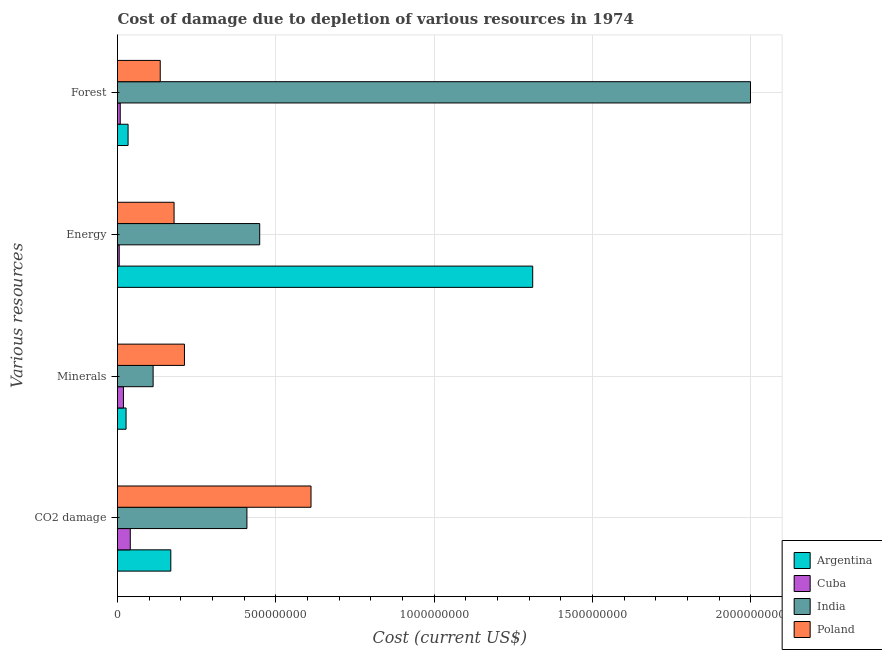How many different coloured bars are there?
Offer a very short reply. 4. How many groups of bars are there?
Offer a terse response. 4. Are the number of bars per tick equal to the number of legend labels?
Keep it short and to the point. Yes. What is the label of the 4th group of bars from the top?
Provide a succinct answer. CO2 damage. What is the cost of damage due to depletion of minerals in Argentina?
Provide a short and direct response. 2.70e+07. Across all countries, what is the maximum cost of damage due to depletion of coal?
Make the answer very short. 6.11e+08. Across all countries, what is the minimum cost of damage due to depletion of energy?
Your answer should be compact. 5.37e+06. In which country was the cost of damage due to depletion of minerals maximum?
Make the answer very short. Poland. In which country was the cost of damage due to depletion of minerals minimum?
Make the answer very short. Cuba. What is the total cost of damage due to depletion of energy in the graph?
Provide a short and direct response. 1.94e+09. What is the difference between the cost of damage due to depletion of energy in India and that in Poland?
Keep it short and to the point. 2.70e+08. What is the difference between the cost of damage due to depletion of coal in Poland and the cost of damage due to depletion of minerals in Argentina?
Offer a very short reply. 5.84e+08. What is the average cost of damage due to depletion of coal per country?
Keep it short and to the point. 3.07e+08. What is the difference between the cost of damage due to depletion of coal and cost of damage due to depletion of forests in Poland?
Give a very brief answer. 4.76e+08. What is the ratio of the cost of damage due to depletion of coal in Cuba to that in India?
Offer a terse response. 0.1. Is the difference between the cost of damage due to depletion of forests in Poland and Argentina greater than the difference between the cost of damage due to depletion of minerals in Poland and Argentina?
Provide a succinct answer. No. What is the difference between the highest and the second highest cost of damage due to depletion of minerals?
Make the answer very short. 9.90e+07. What is the difference between the highest and the lowest cost of damage due to depletion of energy?
Your answer should be very brief. 1.31e+09. Is the sum of the cost of damage due to depletion of forests in India and Argentina greater than the maximum cost of damage due to depletion of energy across all countries?
Your response must be concise. Yes. Is it the case that in every country, the sum of the cost of damage due to depletion of forests and cost of damage due to depletion of coal is greater than the sum of cost of damage due to depletion of energy and cost of damage due to depletion of minerals?
Ensure brevity in your answer.  No. What does the 3rd bar from the bottom in Forest represents?
Provide a short and direct response. India. How many bars are there?
Provide a short and direct response. 16. How many countries are there in the graph?
Provide a succinct answer. 4. What is the difference between two consecutive major ticks on the X-axis?
Your answer should be compact. 5.00e+08. Are the values on the major ticks of X-axis written in scientific E-notation?
Ensure brevity in your answer.  No. Does the graph contain any zero values?
Offer a very short reply. No. How are the legend labels stacked?
Your response must be concise. Vertical. What is the title of the graph?
Give a very brief answer. Cost of damage due to depletion of various resources in 1974 . Does "Seychelles" appear as one of the legend labels in the graph?
Offer a terse response. No. What is the label or title of the X-axis?
Your answer should be very brief. Cost (current US$). What is the label or title of the Y-axis?
Your answer should be compact. Various resources. What is the Cost (current US$) of Argentina in CO2 damage?
Provide a short and direct response. 1.68e+08. What is the Cost (current US$) in Cuba in CO2 damage?
Keep it short and to the point. 4.04e+07. What is the Cost (current US$) in India in CO2 damage?
Your response must be concise. 4.09e+08. What is the Cost (current US$) in Poland in CO2 damage?
Ensure brevity in your answer.  6.11e+08. What is the Cost (current US$) of Argentina in Minerals?
Provide a succinct answer. 2.70e+07. What is the Cost (current US$) of Cuba in Minerals?
Offer a very short reply. 1.88e+07. What is the Cost (current US$) of India in Minerals?
Ensure brevity in your answer.  1.12e+08. What is the Cost (current US$) of Poland in Minerals?
Offer a very short reply. 2.11e+08. What is the Cost (current US$) in Argentina in Energy?
Your response must be concise. 1.31e+09. What is the Cost (current US$) in Cuba in Energy?
Your answer should be compact. 5.37e+06. What is the Cost (current US$) of India in Energy?
Keep it short and to the point. 4.49e+08. What is the Cost (current US$) of Poland in Energy?
Make the answer very short. 1.79e+08. What is the Cost (current US$) in Argentina in Forest?
Provide a short and direct response. 3.34e+07. What is the Cost (current US$) of Cuba in Forest?
Provide a short and direct response. 8.61e+06. What is the Cost (current US$) of India in Forest?
Your response must be concise. 2.00e+09. What is the Cost (current US$) of Poland in Forest?
Provide a succinct answer. 1.35e+08. Across all Various resources, what is the maximum Cost (current US$) in Argentina?
Provide a short and direct response. 1.31e+09. Across all Various resources, what is the maximum Cost (current US$) of Cuba?
Provide a succinct answer. 4.04e+07. Across all Various resources, what is the maximum Cost (current US$) in India?
Give a very brief answer. 2.00e+09. Across all Various resources, what is the maximum Cost (current US$) in Poland?
Your answer should be very brief. 6.11e+08. Across all Various resources, what is the minimum Cost (current US$) of Argentina?
Provide a succinct answer. 2.70e+07. Across all Various resources, what is the minimum Cost (current US$) in Cuba?
Provide a short and direct response. 5.37e+06. Across all Various resources, what is the minimum Cost (current US$) of India?
Offer a terse response. 1.12e+08. Across all Various resources, what is the minimum Cost (current US$) in Poland?
Your answer should be compact. 1.35e+08. What is the total Cost (current US$) of Argentina in the graph?
Ensure brevity in your answer.  1.54e+09. What is the total Cost (current US$) of Cuba in the graph?
Make the answer very short. 7.31e+07. What is the total Cost (current US$) in India in the graph?
Make the answer very short. 2.97e+09. What is the total Cost (current US$) in Poland in the graph?
Offer a terse response. 1.14e+09. What is the difference between the Cost (current US$) of Argentina in CO2 damage and that in Minerals?
Keep it short and to the point. 1.41e+08. What is the difference between the Cost (current US$) of Cuba in CO2 damage and that in Minerals?
Your answer should be very brief. 2.16e+07. What is the difference between the Cost (current US$) of India in CO2 damage and that in Minerals?
Give a very brief answer. 2.96e+08. What is the difference between the Cost (current US$) in Poland in CO2 damage and that in Minerals?
Provide a short and direct response. 4.00e+08. What is the difference between the Cost (current US$) of Argentina in CO2 damage and that in Energy?
Keep it short and to the point. -1.14e+09. What is the difference between the Cost (current US$) of Cuba in CO2 damage and that in Energy?
Your answer should be compact. 3.50e+07. What is the difference between the Cost (current US$) of India in CO2 damage and that in Energy?
Give a very brief answer. -4.04e+07. What is the difference between the Cost (current US$) of Poland in CO2 damage and that in Energy?
Offer a terse response. 4.33e+08. What is the difference between the Cost (current US$) in Argentina in CO2 damage and that in Forest?
Ensure brevity in your answer.  1.35e+08. What is the difference between the Cost (current US$) in Cuba in CO2 damage and that in Forest?
Provide a short and direct response. 3.18e+07. What is the difference between the Cost (current US$) of India in CO2 damage and that in Forest?
Make the answer very short. -1.59e+09. What is the difference between the Cost (current US$) in Poland in CO2 damage and that in Forest?
Your answer should be very brief. 4.76e+08. What is the difference between the Cost (current US$) of Argentina in Minerals and that in Energy?
Give a very brief answer. -1.28e+09. What is the difference between the Cost (current US$) of Cuba in Minerals and that in Energy?
Offer a terse response. 1.34e+07. What is the difference between the Cost (current US$) in India in Minerals and that in Energy?
Make the answer very short. -3.37e+08. What is the difference between the Cost (current US$) of Poland in Minerals and that in Energy?
Your answer should be compact. 3.28e+07. What is the difference between the Cost (current US$) in Argentina in Minerals and that in Forest?
Ensure brevity in your answer.  -6.35e+06. What is the difference between the Cost (current US$) of Cuba in Minerals and that in Forest?
Keep it short and to the point. 1.01e+07. What is the difference between the Cost (current US$) of India in Minerals and that in Forest?
Give a very brief answer. -1.89e+09. What is the difference between the Cost (current US$) of Poland in Minerals and that in Forest?
Offer a very short reply. 7.65e+07. What is the difference between the Cost (current US$) in Argentina in Energy and that in Forest?
Offer a terse response. 1.28e+09. What is the difference between the Cost (current US$) of Cuba in Energy and that in Forest?
Offer a terse response. -3.24e+06. What is the difference between the Cost (current US$) of India in Energy and that in Forest?
Offer a terse response. -1.55e+09. What is the difference between the Cost (current US$) in Poland in Energy and that in Forest?
Provide a short and direct response. 4.37e+07. What is the difference between the Cost (current US$) of Argentina in CO2 damage and the Cost (current US$) of Cuba in Minerals?
Your answer should be compact. 1.50e+08. What is the difference between the Cost (current US$) of Argentina in CO2 damage and the Cost (current US$) of India in Minerals?
Make the answer very short. 5.59e+07. What is the difference between the Cost (current US$) of Argentina in CO2 damage and the Cost (current US$) of Poland in Minerals?
Provide a succinct answer. -4.31e+07. What is the difference between the Cost (current US$) of Cuba in CO2 damage and the Cost (current US$) of India in Minerals?
Your answer should be compact. -7.21e+07. What is the difference between the Cost (current US$) of Cuba in CO2 damage and the Cost (current US$) of Poland in Minerals?
Keep it short and to the point. -1.71e+08. What is the difference between the Cost (current US$) in India in CO2 damage and the Cost (current US$) in Poland in Minerals?
Your response must be concise. 1.97e+08. What is the difference between the Cost (current US$) in Argentina in CO2 damage and the Cost (current US$) in Cuba in Energy?
Your answer should be compact. 1.63e+08. What is the difference between the Cost (current US$) of Argentina in CO2 damage and the Cost (current US$) of India in Energy?
Keep it short and to the point. -2.81e+08. What is the difference between the Cost (current US$) of Argentina in CO2 damage and the Cost (current US$) of Poland in Energy?
Offer a terse response. -1.03e+07. What is the difference between the Cost (current US$) of Cuba in CO2 damage and the Cost (current US$) of India in Energy?
Provide a short and direct response. -4.09e+08. What is the difference between the Cost (current US$) of Cuba in CO2 damage and the Cost (current US$) of Poland in Energy?
Give a very brief answer. -1.38e+08. What is the difference between the Cost (current US$) in India in CO2 damage and the Cost (current US$) in Poland in Energy?
Keep it short and to the point. 2.30e+08. What is the difference between the Cost (current US$) in Argentina in CO2 damage and the Cost (current US$) in Cuba in Forest?
Ensure brevity in your answer.  1.60e+08. What is the difference between the Cost (current US$) in Argentina in CO2 damage and the Cost (current US$) in India in Forest?
Provide a short and direct response. -1.83e+09. What is the difference between the Cost (current US$) in Argentina in CO2 damage and the Cost (current US$) in Poland in Forest?
Make the answer very short. 3.34e+07. What is the difference between the Cost (current US$) in Cuba in CO2 damage and the Cost (current US$) in India in Forest?
Offer a very short reply. -1.96e+09. What is the difference between the Cost (current US$) in Cuba in CO2 damage and the Cost (current US$) in Poland in Forest?
Your answer should be compact. -9.46e+07. What is the difference between the Cost (current US$) of India in CO2 damage and the Cost (current US$) of Poland in Forest?
Provide a short and direct response. 2.74e+08. What is the difference between the Cost (current US$) of Argentina in Minerals and the Cost (current US$) of Cuba in Energy?
Keep it short and to the point. 2.17e+07. What is the difference between the Cost (current US$) of Argentina in Minerals and the Cost (current US$) of India in Energy?
Offer a very short reply. -4.22e+08. What is the difference between the Cost (current US$) in Argentina in Minerals and the Cost (current US$) in Poland in Energy?
Your answer should be very brief. -1.52e+08. What is the difference between the Cost (current US$) in Cuba in Minerals and the Cost (current US$) in India in Energy?
Your answer should be compact. -4.30e+08. What is the difference between the Cost (current US$) in Cuba in Minerals and the Cost (current US$) in Poland in Energy?
Provide a succinct answer. -1.60e+08. What is the difference between the Cost (current US$) of India in Minerals and the Cost (current US$) of Poland in Energy?
Offer a terse response. -6.62e+07. What is the difference between the Cost (current US$) in Argentina in Minerals and the Cost (current US$) in Cuba in Forest?
Your answer should be very brief. 1.84e+07. What is the difference between the Cost (current US$) of Argentina in Minerals and the Cost (current US$) of India in Forest?
Ensure brevity in your answer.  -1.97e+09. What is the difference between the Cost (current US$) in Argentina in Minerals and the Cost (current US$) in Poland in Forest?
Your response must be concise. -1.08e+08. What is the difference between the Cost (current US$) of Cuba in Minerals and the Cost (current US$) of India in Forest?
Give a very brief answer. -1.98e+09. What is the difference between the Cost (current US$) of Cuba in Minerals and the Cost (current US$) of Poland in Forest?
Offer a very short reply. -1.16e+08. What is the difference between the Cost (current US$) in India in Minerals and the Cost (current US$) in Poland in Forest?
Make the answer very short. -2.25e+07. What is the difference between the Cost (current US$) in Argentina in Energy and the Cost (current US$) in Cuba in Forest?
Your response must be concise. 1.30e+09. What is the difference between the Cost (current US$) in Argentina in Energy and the Cost (current US$) in India in Forest?
Offer a terse response. -6.88e+08. What is the difference between the Cost (current US$) in Argentina in Energy and the Cost (current US$) in Poland in Forest?
Make the answer very short. 1.18e+09. What is the difference between the Cost (current US$) of Cuba in Energy and the Cost (current US$) of India in Forest?
Your response must be concise. -1.99e+09. What is the difference between the Cost (current US$) in Cuba in Energy and the Cost (current US$) in Poland in Forest?
Your answer should be very brief. -1.30e+08. What is the difference between the Cost (current US$) in India in Energy and the Cost (current US$) in Poland in Forest?
Give a very brief answer. 3.14e+08. What is the average Cost (current US$) of Argentina per Various resources?
Offer a terse response. 3.85e+08. What is the average Cost (current US$) in Cuba per Various resources?
Your answer should be very brief. 1.83e+07. What is the average Cost (current US$) in India per Various resources?
Keep it short and to the point. 7.42e+08. What is the average Cost (current US$) of Poland per Various resources?
Offer a terse response. 2.84e+08. What is the difference between the Cost (current US$) of Argentina and Cost (current US$) of Cuba in CO2 damage?
Offer a very short reply. 1.28e+08. What is the difference between the Cost (current US$) in Argentina and Cost (current US$) in India in CO2 damage?
Your answer should be very brief. -2.40e+08. What is the difference between the Cost (current US$) of Argentina and Cost (current US$) of Poland in CO2 damage?
Make the answer very short. -4.43e+08. What is the difference between the Cost (current US$) in Cuba and Cost (current US$) in India in CO2 damage?
Ensure brevity in your answer.  -3.68e+08. What is the difference between the Cost (current US$) in Cuba and Cost (current US$) in Poland in CO2 damage?
Your answer should be very brief. -5.71e+08. What is the difference between the Cost (current US$) in India and Cost (current US$) in Poland in CO2 damage?
Your response must be concise. -2.02e+08. What is the difference between the Cost (current US$) in Argentina and Cost (current US$) in Cuba in Minerals?
Provide a short and direct response. 8.27e+06. What is the difference between the Cost (current US$) in Argentina and Cost (current US$) in India in Minerals?
Keep it short and to the point. -8.55e+07. What is the difference between the Cost (current US$) in Argentina and Cost (current US$) in Poland in Minerals?
Offer a very short reply. -1.84e+08. What is the difference between the Cost (current US$) in Cuba and Cost (current US$) in India in Minerals?
Provide a short and direct response. -9.37e+07. What is the difference between the Cost (current US$) of Cuba and Cost (current US$) of Poland in Minerals?
Give a very brief answer. -1.93e+08. What is the difference between the Cost (current US$) in India and Cost (current US$) in Poland in Minerals?
Ensure brevity in your answer.  -9.90e+07. What is the difference between the Cost (current US$) of Argentina and Cost (current US$) of Cuba in Energy?
Provide a succinct answer. 1.31e+09. What is the difference between the Cost (current US$) in Argentina and Cost (current US$) in India in Energy?
Make the answer very short. 8.62e+08. What is the difference between the Cost (current US$) of Argentina and Cost (current US$) of Poland in Energy?
Give a very brief answer. 1.13e+09. What is the difference between the Cost (current US$) in Cuba and Cost (current US$) in India in Energy?
Provide a succinct answer. -4.44e+08. What is the difference between the Cost (current US$) in Cuba and Cost (current US$) in Poland in Energy?
Ensure brevity in your answer.  -1.73e+08. What is the difference between the Cost (current US$) of India and Cost (current US$) of Poland in Energy?
Give a very brief answer. 2.70e+08. What is the difference between the Cost (current US$) in Argentina and Cost (current US$) in Cuba in Forest?
Offer a very short reply. 2.48e+07. What is the difference between the Cost (current US$) of Argentina and Cost (current US$) of India in Forest?
Make the answer very short. -1.97e+09. What is the difference between the Cost (current US$) of Argentina and Cost (current US$) of Poland in Forest?
Your answer should be very brief. -1.02e+08. What is the difference between the Cost (current US$) in Cuba and Cost (current US$) in India in Forest?
Ensure brevity in your answer.  -1.99e+09. What is the difference between the Cost (current US$) in Cuba and Cost (current US$) in Poland in Forest?
Keep it short and to the point. -1.26e+08. What is the difference between the Cost (current US$) in India and Cost (current US$) in Poland in Forest?
Your answer should be very brief. 1.86e+09. What is the ratio of the Cost (current US$) in Argentina in CO2 damage to that in Minerals?
Your answer should be very brief. 6.23. What is the ratio of the Cost (current US$) of Cuba in CO2 damage to that in Minerals?
Your answer should be very brief. 2.15. What is the ratio of the Cost (current US$) of India in CO2 damage to that in Minerals?
Make the answer very short. 3.63. What is the ratio of the Cost (current US$) of Poland in CO2 damage to that in Minerals?
Ensure brevity in your answer.  2.89. What is the ratio of the Cost (current US$) of Argentina in CO2 damage to that in Energy?
Offer a terse response. 0.13. What is the ratio of the Cost (current US$) of Cuba in CO2 damage to that in Energy?
Provide a succinct answer. 7.52. What is the ratio of the Cost (current US$) of India in CO2 damage to that in Energy?
Provide a succinct answer. 0.91. What is the ratio of the Cost (current US$) of Poland in CO2 damage to that in Energy?
Provide a short and direct response. 3.42. What is the ratio of the Cost (current US$) of Argentina in CO2 damage to that in Forest?
Your answer should be compact. 5.04. What is the ratio of the Cost (current US$) of Cuba in CO2 damage to that in Forest?
Offer a very short reply. 4.69. What is the ratio of the Cost (current US$) in India in CO2 damage to that in Forest?
Your response must be concise. 0.2. What is the ratio of the Cost (current US$) in Poland in CO2 damage to that in Forest?
Provide a short and direct response. 4.53. What is the ratio of the Cost (current US$) in Argentina in Minerals to that in Energy?
Your answer should be compact. 0.02. What is the ratio of the Cost (current US$) in Cuba in Minerals to that in Energy?
Ensure brevity in your answer.  3.49. What is the ratio of the Cost (current US$) of India in Minerals to that in Energy?
Offer a terse response. 0.25. What is the ratio of the Cost (current US$) of Poland in Minerals to that in Energy?
Provide a succinct answer. 1.18. What is the ratio of the Cost (current US$) of Argentina in Minerals to that in Forest?
Your response must be concise. 0.81. What is the ratio of the Cost (current US$) in Cuba in Minerals to that in Forest?
Your response must be concise. 2.18. What is the ratio of the Cost (current US$) in India in Minerals to that in Forest?
Give a very brief answer. 0.06. What is the ratio of the Cost (current US$) in Poland in Minerals to that in Forest?
Offer a terse response. 1.57. What is the ratio of the Cost (current US$) of Argentina in Energy to that in Forest?
Provide a succinct answer. 39.28. What is the ratio of the Cost (current US$) of Cuba in Energy to that in Forest?
Your answer should be very brief. 0.62. What is the ratio of the Cost (current US$) of India in Energy to that in Forest?
Make the answer very short. 0.22. What is the ratio of the Cost (current US$) in Poland in Energy to that in Forest?
Offer a very short reply. 1.32. What is the difference between the highest and the second highest Cost (current US$) in Argentina?
Your answer should be very brief. 1.14e+09. What is the difference between the highest and the second highest Cost (current US$) in Cuba?
Offer a terse response. 2.16e+07. What is the difference between the highest and the second highest Cost (current US$) in India?
Give a very brief answer. 1.55e+09. What is the difference between the highest and the second highest Cost (current US$) in Poland?
Make the answer very short. 4.00e+08. What is the difference between the highest and the lowest Cost (current US$) of Argentina?
Offer a very short reply. 1.28e+09. What is the difference between the highest and the lowest Cost (current US$) of Cuba?
Give a very brief answer. 3.50e+07. What is the difference between the highest and the lowest Cost (current US$) in India?
Your response must be concise. 1.89e+09. What is the difference between the highest and the lowest Cost (current US$) of Poland?
Your answer should be compact. 4.76e+08. 